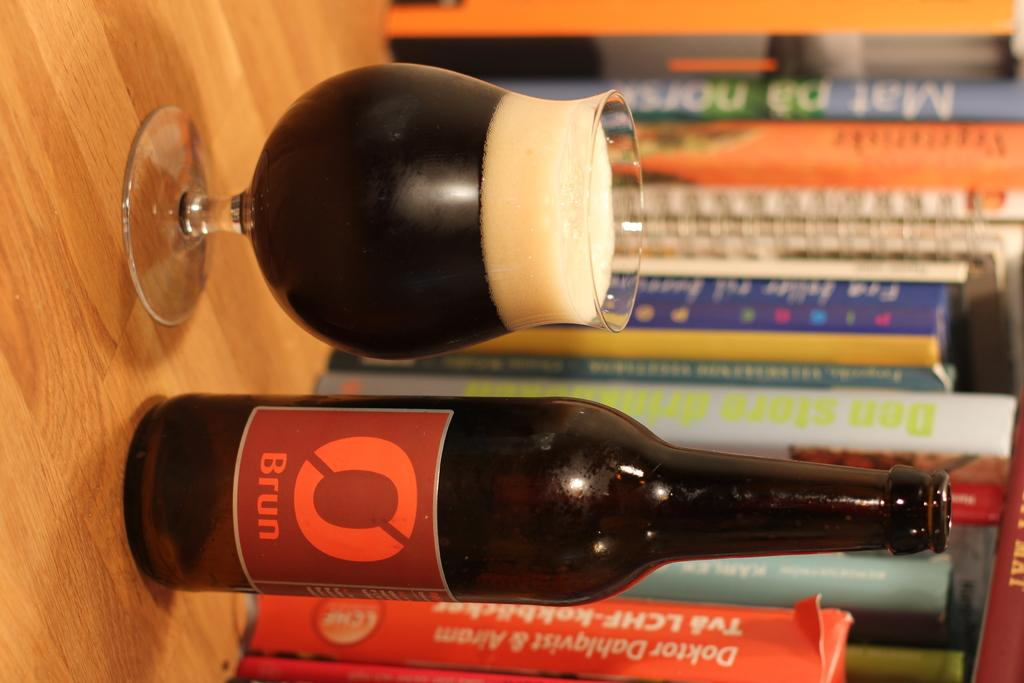<image>
Offer a succinct explanation of the picture presented. Bottle of BRUN in front of some books on a shelf. 